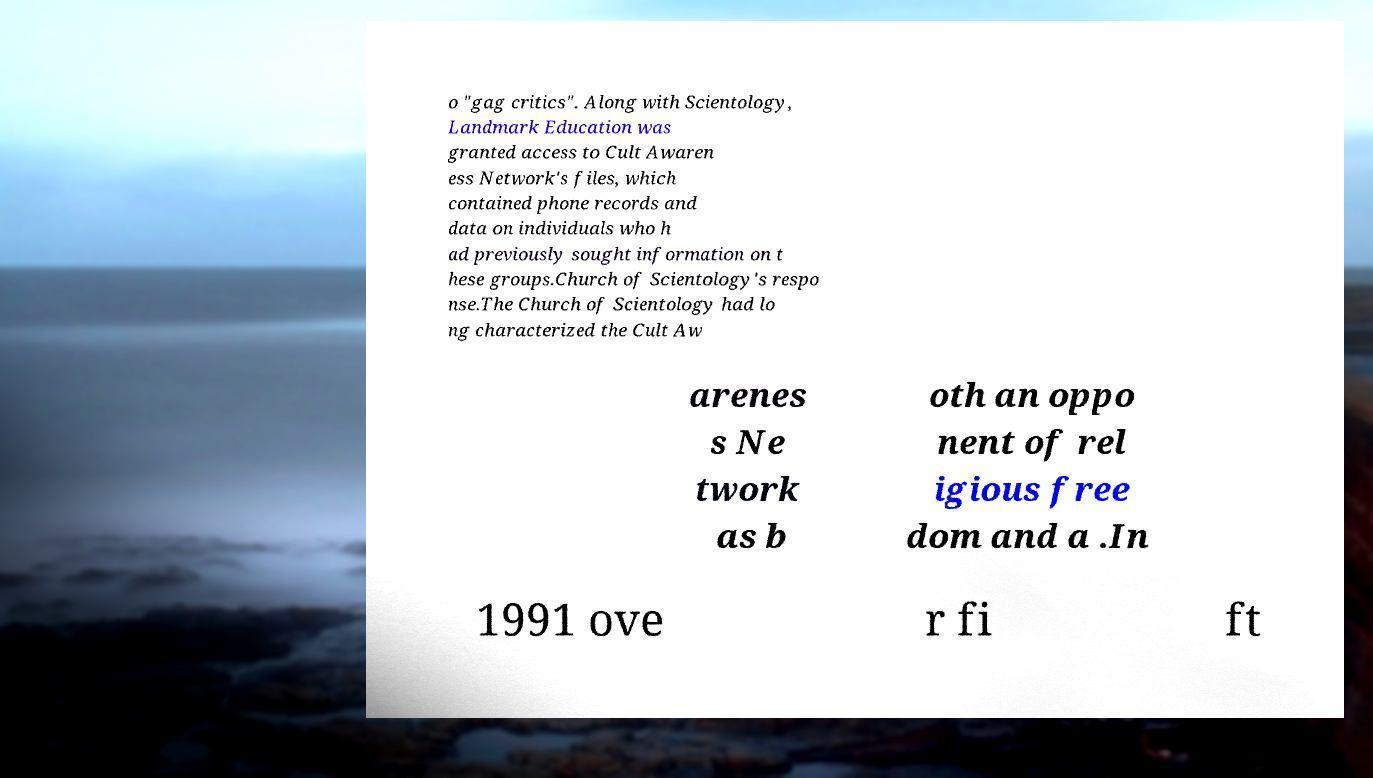Could you assist in decoding the text presented in this image and type it out clearly? o "gag critics". Along with Scientology, Landmark Education was granted access to Cult Awaren ess Network's files, which contained phone records and data on individuals who h ad previously sought information on t hese groups.Church of Scientology's respo nse.The Church of Scientology had lo ng characterized the Cult Aw arenes s Ne twork as b oth an oppo nent of rel igious free dom and a .In 1991 ove r fi ft 